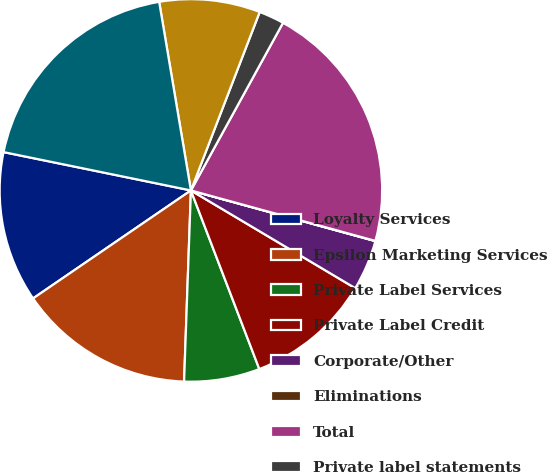Convert chart. <chart><loc_0><loc_0><loc_500><loc_500><pie_chart><fcel>Loyalty Services<fcel>Epsilon Marketing Services<fcel>Private Label Services<fcel>Private Label Credit<fcel>Corporate/Other<fcel>Eliminations<fcel>Total<fcel>Private label statements<fcel>Credit sales<fcel>Average managed receivables<nl><fcel>12.76%<fcel>14.88%<fcel>6.39%<fcel>10.64%<fcel>4.27%<fcel>0.02%<fcel>21.25%<fcel>2.14%<fcel>8.51%<fcel>19.13%<nl></chart> 